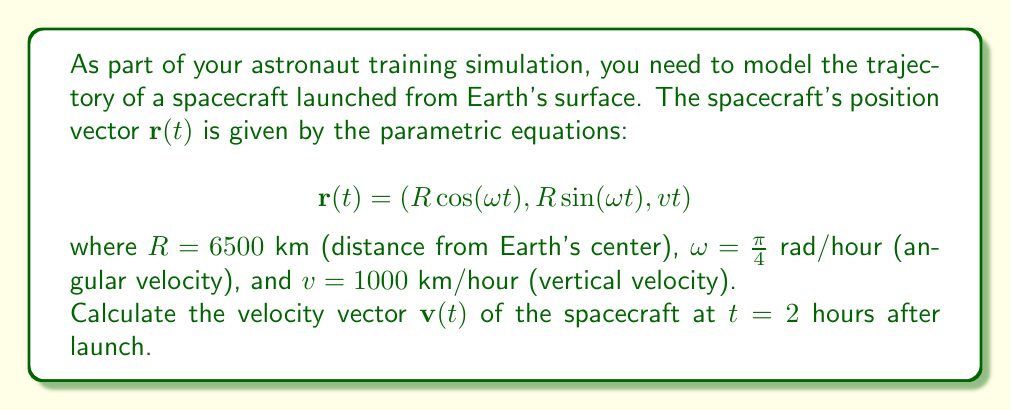Provide a solution to this math problem. To solve this problem, we need to follow these steps:

1) The velocity vector $\mathbf{v}(t)$ is the derivative of the position vector $\mathbf{r}(t)$ with respect to time. So, we need to differentiate each component of $\mathbf{r}(t)$.

2) Let's differentiate each component:

   For x: $\frac{d}{dt}(R \cos(\omega t)) = -R\omega \sin(\omega t)$
   For y: $\frac{d}{dt}(R \sin(\omega t)) = R\omega \cos(\omega t)$
   For z: $\frac{d}{dt}(vt) = v$

3) Therefore, the velocity vector is:

   $$\mathbf{v}(t) = \left(-R\omega \sin(\omega t), R\omega \cos(\omega t), v\right)$$

4) Now, we need to substitute the given values and $t = 2$:

   $R = 6500$ km
   $\omega = \frac{\pi}{4}$ rad/hour
   $v = 1000$ km/hour
   $t = 2$ hours

5) Let's calculate each component:

   x: $-6500 \cdot \frac{\pi}{4} \cdot \sin(\frac{\pi}{4} \cdot 2) = -6500 \cdot \frac{\pi}{4} \cdot \sin(\frac{\pi}{2}) = -6500 \cdot \frac{\pi}{4} \approx -5104.72$ km/hour

   y: $6500 \cdot \frac{\pi}{4} \cdot \cos(\frac{\pi}{4} \cdot 2) = 6500 \cdot \frac{\pi}{4} \cdot \cos(\frac{\pi}{2}) = 0$ km/hour

   z: $1000$ km/hour (unchanged)

6) Therefore, the velocity vector at $t = 2$ hours is approximately:

   $$\mathbf{v}(2) \approx (-5104.72, 0, 1000)$$ km/hour
Answer: $$\mathbf{v}(2) \approx (-5104.72, 0, 1000)$$ km/hour 